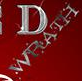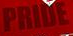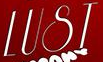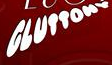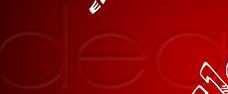Identify the words shown in these images in order, separated by a semicolon. WRATH; PRIDE; LUST; GLUTTONV; dea 